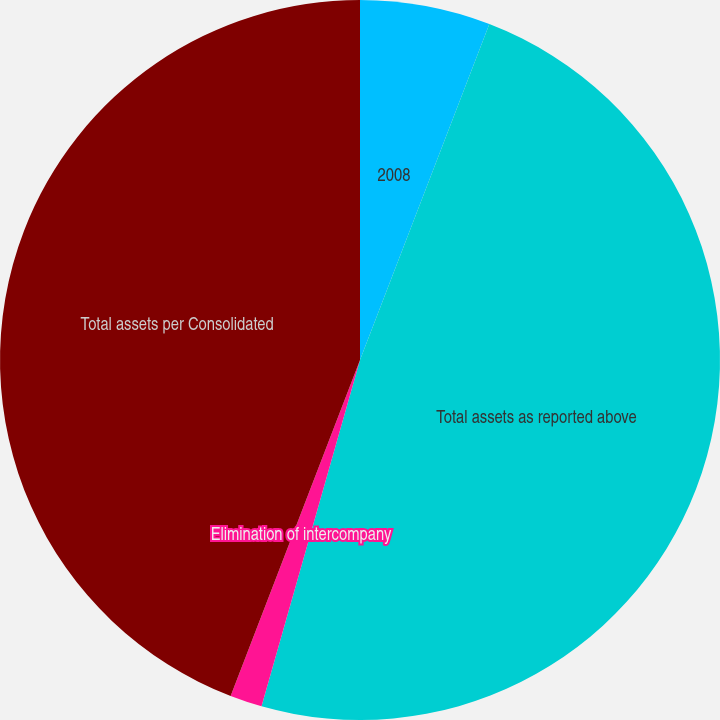Convert chart to OTSL. <chart><loc_0><loc_0><loc_500><loc_500><pie_chart><fcel>2008<fcel>Total assets as reported above<fcel>Elimination of intercompany<fcel>Total assets per Consolidated<nl><fcel>5.85%<fcel>48.56%<fcel>1.44%<fcel>44.15%<nl></chart> 